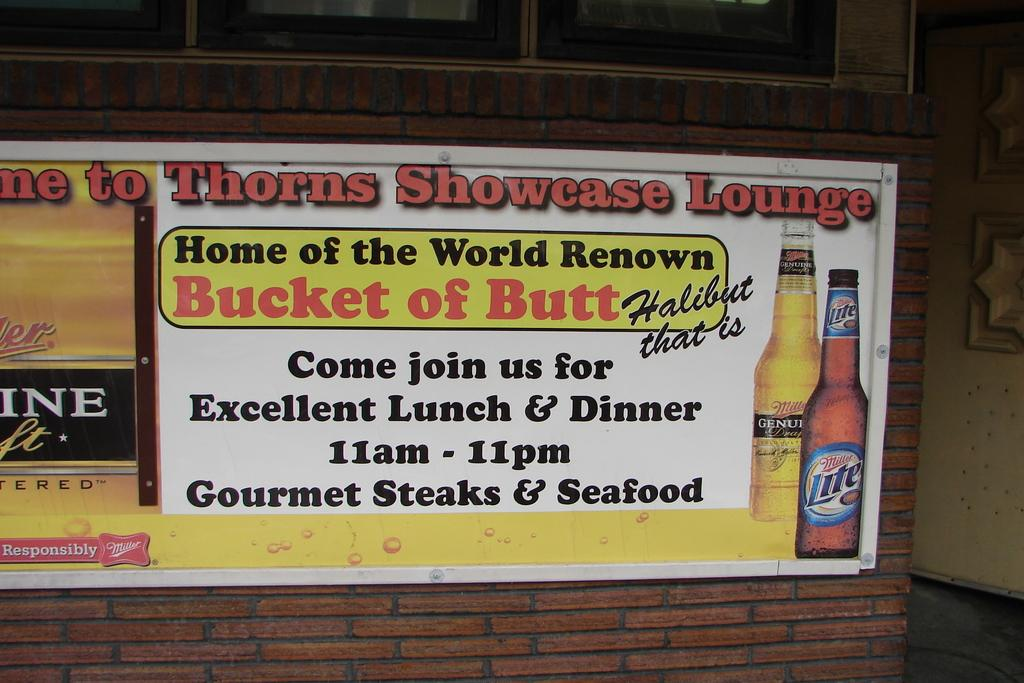<image>
Describe the image concisely. A sign for the Thorns Showcase Lounge that says come join us. 